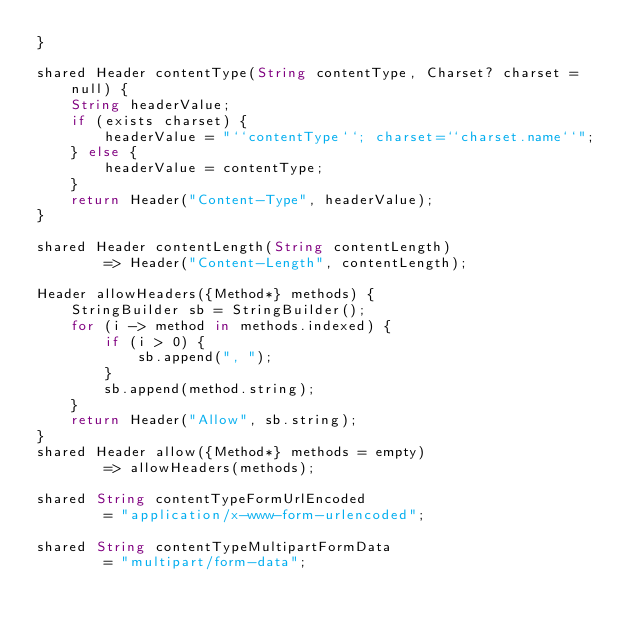Convert code to text. <code><loc_0><loc_0><loc_500><loc_500><_Ceylon_>}

shared Header contentType(String contentType, Charset? charset = null) {
    String headerValue;
    if (exists charset) {
        headerValue = "``contentType``; charset=``charset.name``";
    } else {
        headerValue = contentType;
    }
    return Header("Content-Type", headerValue);
}

shared Header contentLength(String contentLength) 
        => Header("Content-Length", contentLength);

Header allowHeaders({Method*} methods) {
    StringBuilder sb = StringBuilder();
    for (i -> method in methods.indexed) {
        if (i > 0) {
            sb.append(", ");
        }
        sb.append(method.string);
    }
    return Header("Allow", sb.string);
}
shared Header allow({Method*} methods = empty) 
        => allowHeaders(methods);

shared String contentTypeFormUrlEncoded 
        = "application/x-www-form-urlencoded";

shared String contentTypeMultipartFormData 
        = "multipart/form-data";
</code> 